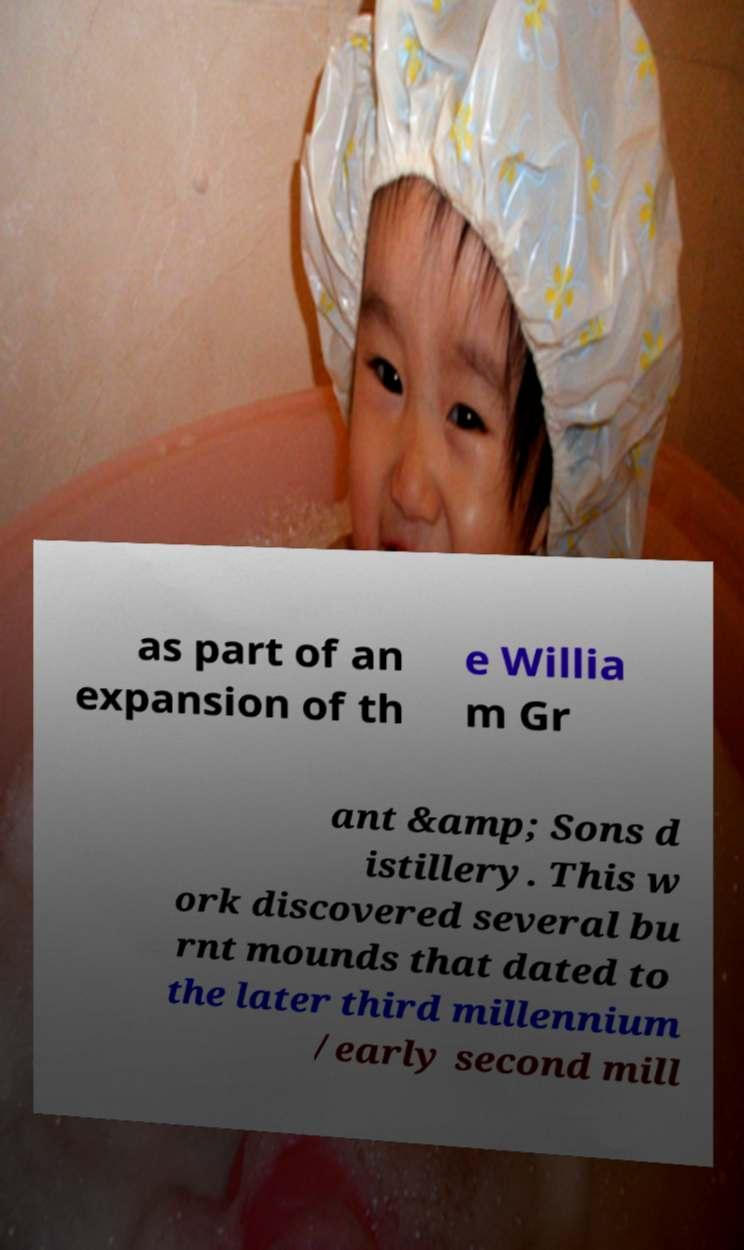Please identify and transcribe the text found in this image. as part of an expansion of th e Willia m Gr ant &amp; Sons d istillery. This w ork discovered several bu rnt mounds that dated to the later third millennium /early second mill 